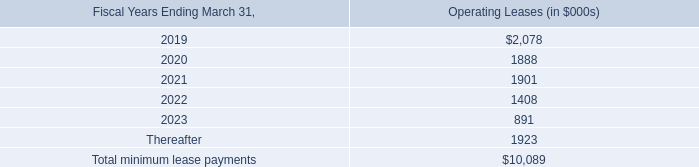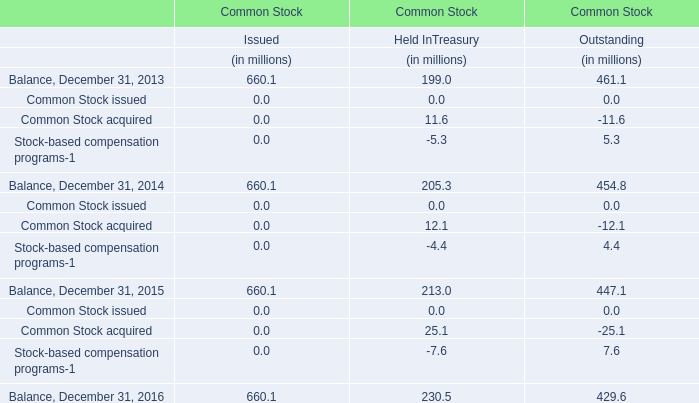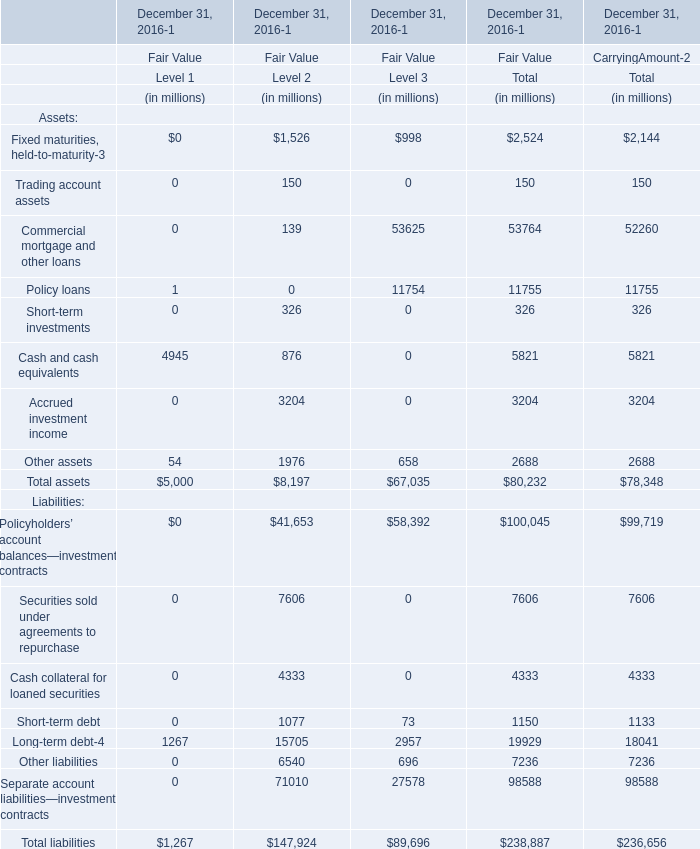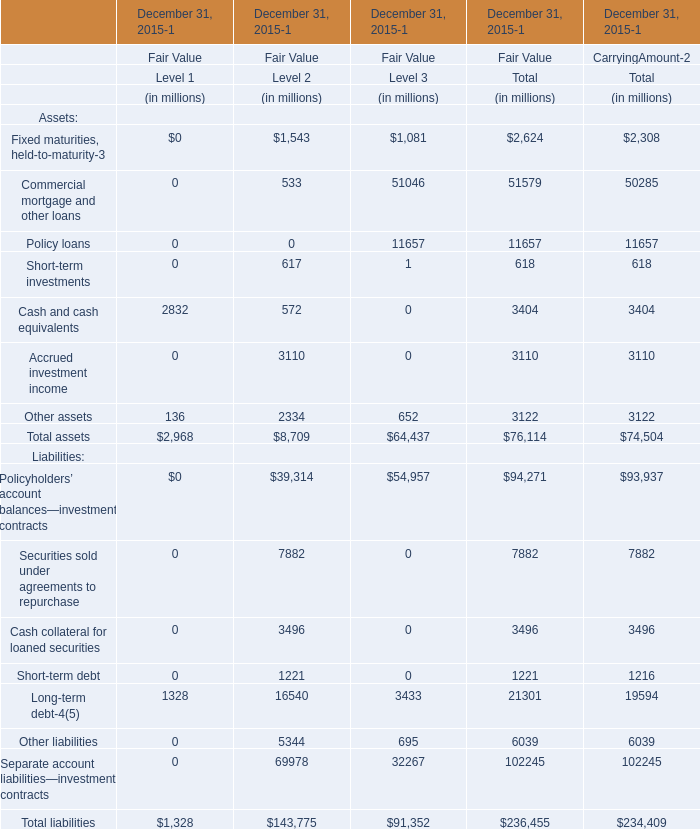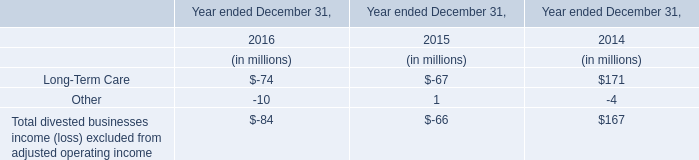Does the proportion of Policy loans in total larger than that of Cash and cash equivalents in total fair value? 
Computations: ((11657 / 76114) - (3404 / 76114))
Answer: 0.10843. 